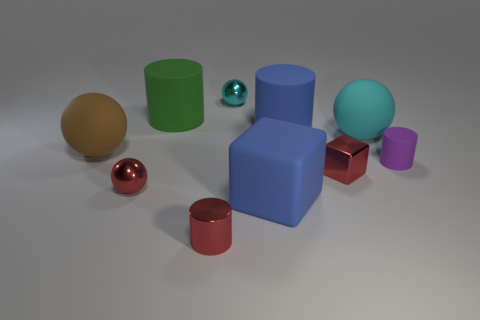What material is the big cylinder that is the same color as the large block?
Provide a short and direct response. Rubber. Do the tiny metallic cube and the large matte sphere that is right of the blue rubber cylinder have the same color?
Give a very brief answer. No. How many other objects are the same color as the tiny rubber object?
Your answer should be very brief. 0. There is a thing to the right of the large cyan object; is its size the same as the metallic ball in front of the green rubber cylinder?
Your answer should be very brief. Yes. The cube behind the blue matte cube is what color?
Provide a short and direct response. Red. Is the number of tiny cubes that are in front of the blue rubber cylinder less than the number of gray cylinders?
Offer a terse response. No. Does the large cyan thing have the same material as the blue cube?
Your answer should be very brief. Yes. There is a red thing that is the same shape as the small purple rubber thing; what is its size?
Provide a succinct answer. Small. What number of objects are small metallic balls on the left side of the red cylinder or things that are right of the big blue cube?
Your answer should be compact. 5. Is the number of gray metallic cylinders less than the number of large spheres?
Provide a short and direct response. Yes. 